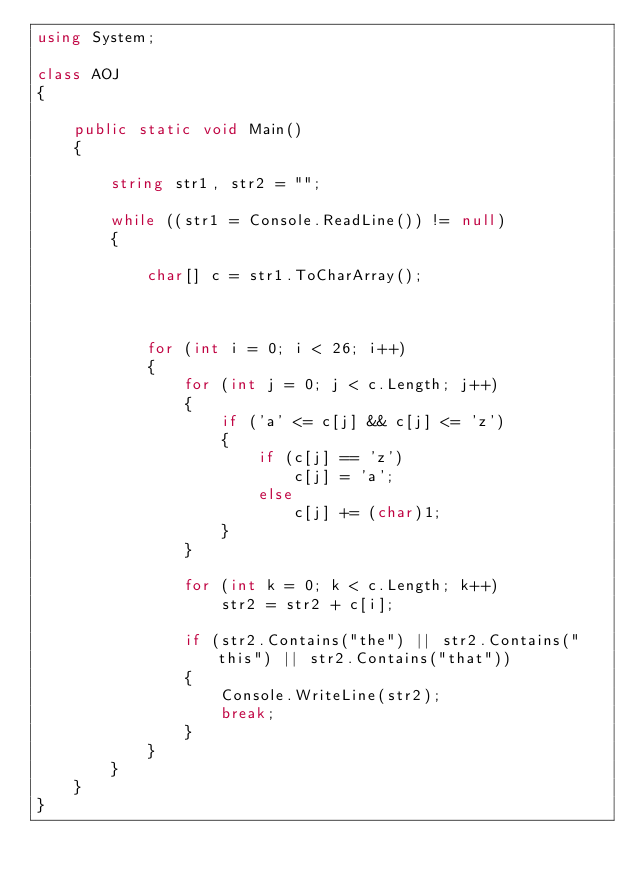<code> <loc_0><loc_0><loc_500><loc_500><_C#_>using System;

class AOJ
{

    public static void Main()
    {

        string str1, str2 = "";

        while ((str1 = Console.ReadLine()) != null)
        {

            char[] c = str1.ToCharArray();



            for (int i = 0; i < 26; i++)
            {
                for (int j = 0; j < c.Length; j++)
                {
                    if ('a' <= c[j] && c[j] <= 'z')
                    {
                        if (c[j] == 'z')
                            c[j] = 'a';
                        else
                            c[j] += (char)1;
                    }
                }

                for (int k = 0; k < c.Length; k++)
                    str2 = str2 + c[i];

                if (str2.Contains("the") || str2.Contains("this") || str2.Contains("that"))
                {
                    Console.WriteLine(str2);
                    break;
                }
            }
        }
    }
}</code> 